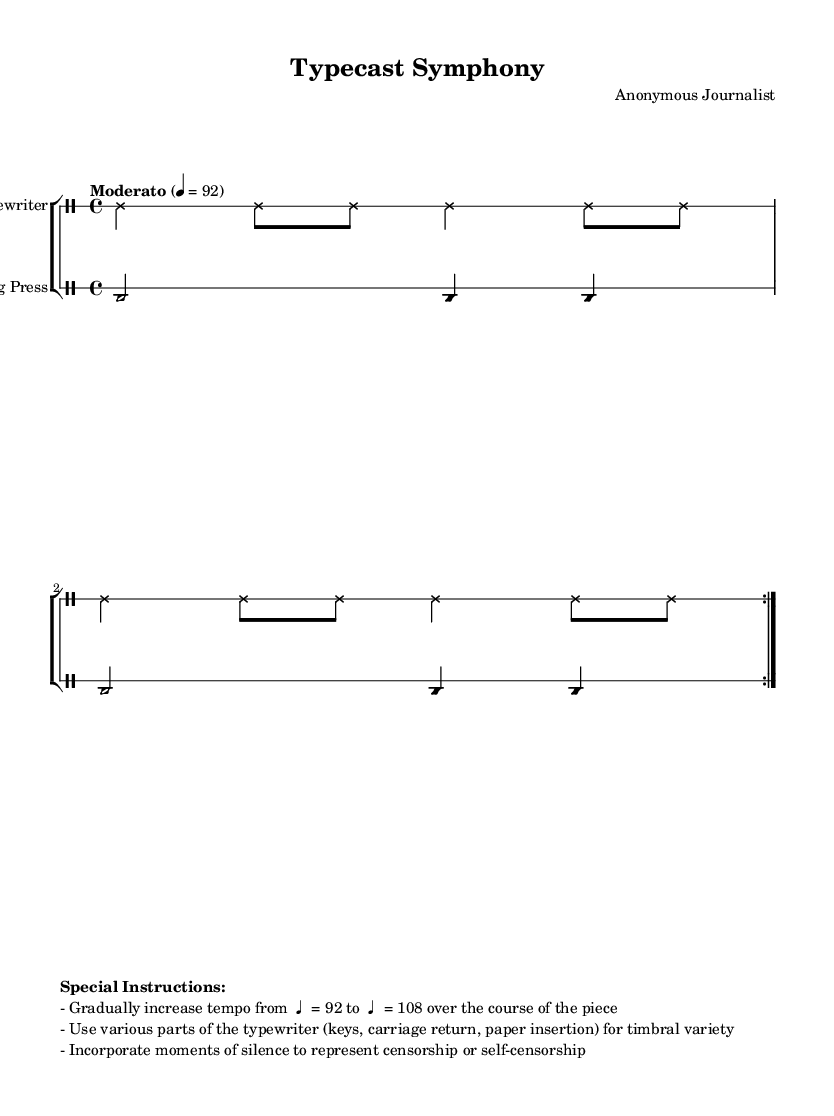What is the time signature of this music? The time signature is indicated at the beginning of the piece and is written as "4/4," which means there are four beats in each measure.
Answer: 4/4 What is the tempo for this composition? The tempo marking states "Moderato" followed by "4 = 92," which indicates a moderate speed at 92 beats per minute.
Answer: 92 How many lines does the staff have for the typewriter? The score specifies the number of lines in the staff by using the command `\override Staff.StaffSymbol.line-count = #1`, meaning there is only one line for the typewriter.
Answer: 1 How does the tempo change throughout the piece? The special instructions indicate that the tempo gradually increases from 92 to 108 beats per minute over the length of the piece, suggesting a gradual acceleration.
Answer: From 92 to 108 What instruments are depicted in this score? The score features two distinct instruments indicated by the instrument names in the DrumStaff for both sections: "Typewriter" and "Printing Press."
Answer: Typewriter and Printing Press How many times is the typewriter pattern repeated? The typewriter pattern is explicitly noted to be repeated twice as indicated by `\repeat volta 2` in the coding.
Answer: 2 What characteristic is highlighted in the special instructions regarding silence? The special instructions mention incorporating moments of silence to represent concepts of censorship or self-censorship, indicating a conceptual depth to the performance.
Answer: Censorship 